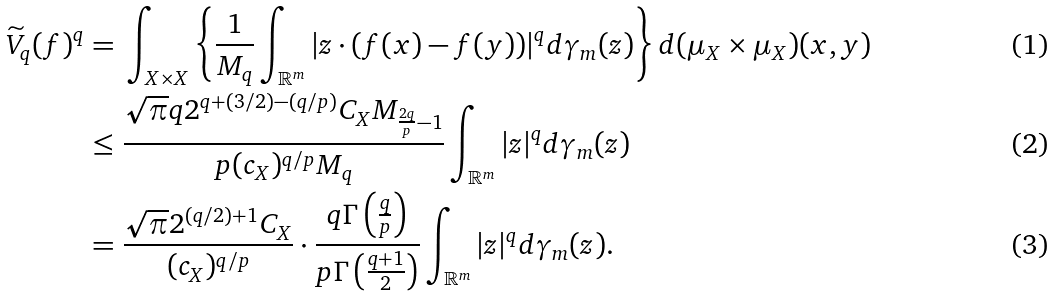Convert formula to latex. <formula><loc_0><loc_0><loc_500><loc_500>\widetilde { V } _ { q } ( f ) ^ { q } = \ & \int _ { X \times X } \left \{ \frac { 1 } { M _ { q } } \int _ { \mathbb { R } ^ { m } } | z \cdot ( f ( x ) - f ( y ) ) | ^ { q } d \gamma _ { m } ( z ) \right \} d ( \mu _ { X } \times \mu _ { X } ) ( x , y ) \\ \leq \ & \frac { \sqrt { \pi } q 2 ^ { q + ( 3 / 2 ) - ( q / p ) } C _ { X } M _ { \frac { 2 q } { p } - 1 } } { p ( c _ { X } ) ^ { q / p } M _ { q } } \int _ { \mathbb { R } ^ { m } } | z | ^ { q } d \gamma _ { m } ( z ) \\ = \ & \frac { \sqrt { \pi } 2 ^ { ( q / 2 ) + 1 } C _ { X } } { ( c _ { X } ) ^ { q / p } } \cdot \frac { q \Gamma \left ( \frac { q } { p } \right ) } { p \Gamma \left ( \frac { q + 1 } { 2 } \right ) } \int _ { \mathbb { R } ^ { m } } | z | ^ { q } d \gamma _ { m } ( z ) .</formula> 